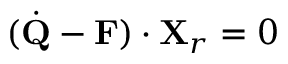<formula> <loc_0><loc_0><loc_500><loc_500>( { \dot { Q } } - { F } ) \cdot { X } _ { r } = 0</formula> 